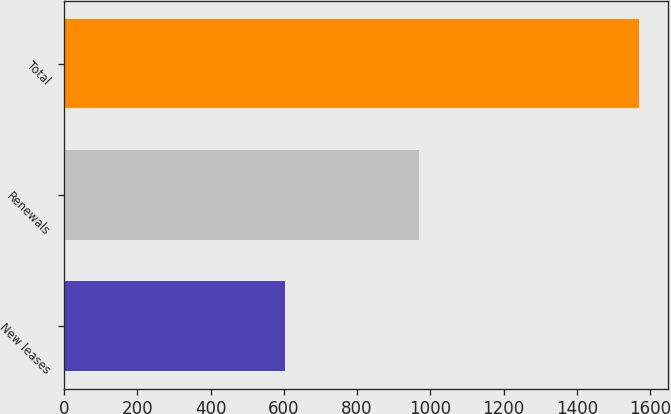<chart> <loc_0><loc_0><loc_500><loc_500><bar_chart><fcel>New leases<fcel>Renewals<fcel>Total<nl><fcel>603<fcel>968<fcel>1571<nl></chart> 